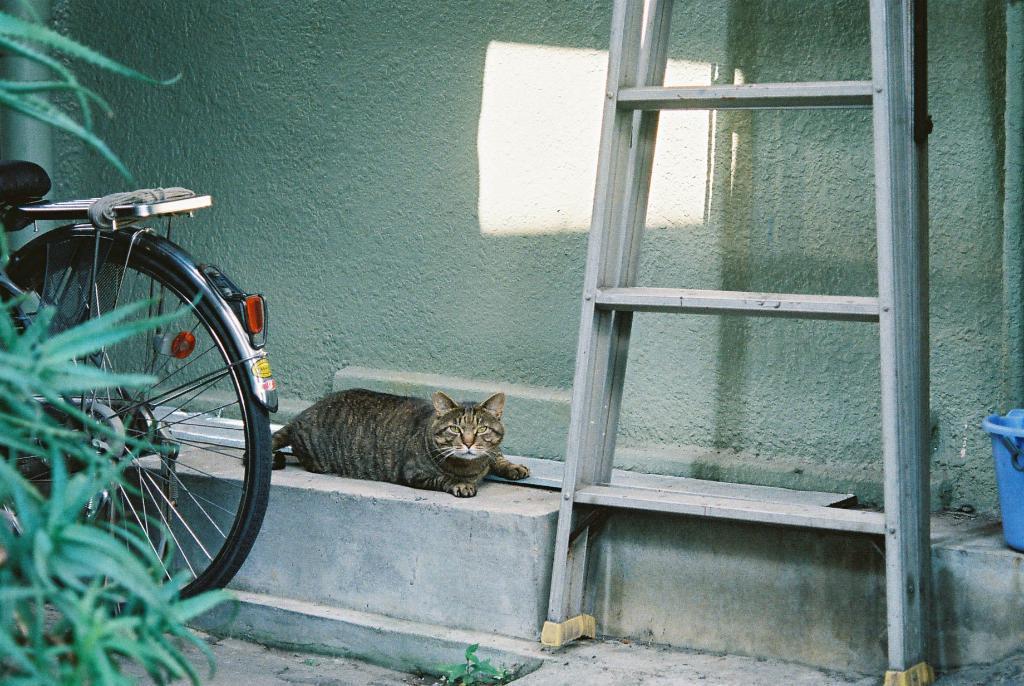Could you give a brief overview of what you see in this image? In the image there is a cat lying on the cement bench, behind the cat there is a wall and in front of the wall there is a ladder, cycle and plants. 